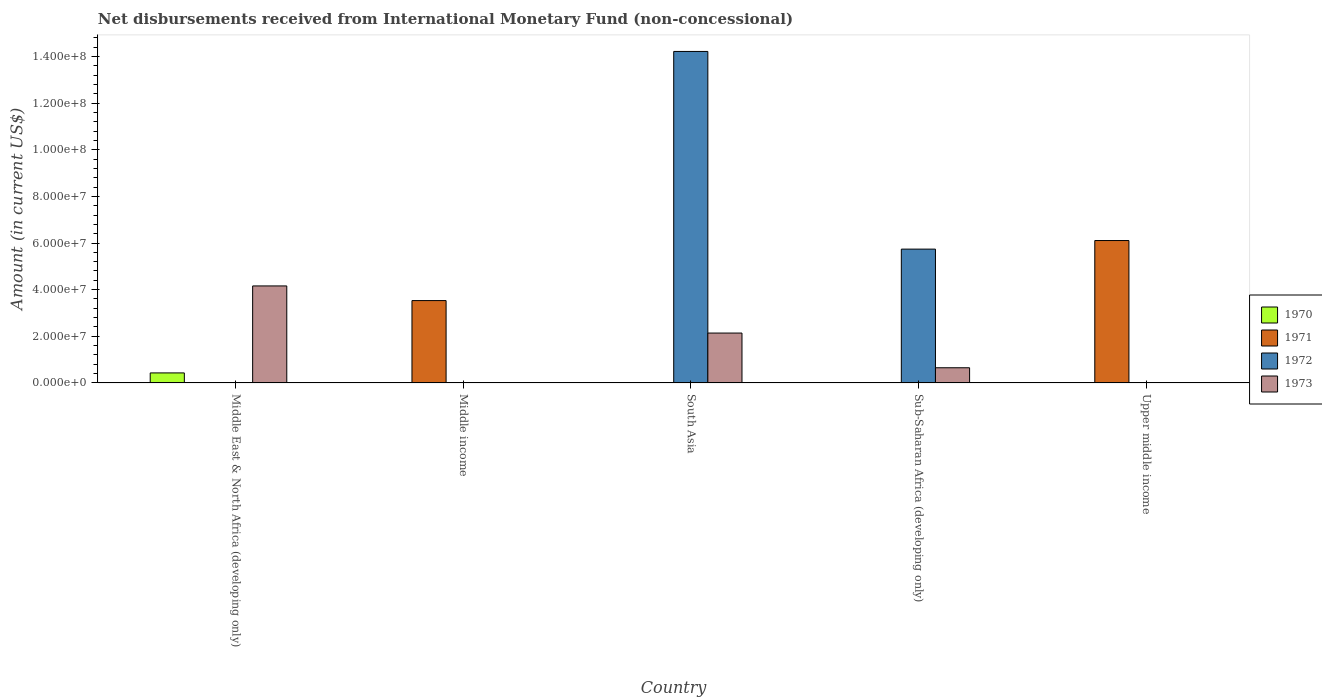How many different coloured bars are there?
Ensure brevity in your answer.  4. What is the label of the 4th group of bars from the left?
Provide a short and direct response. Sub-Saharan Africa (developing only). What is the amount of disbursements received from International Monetary Fund in 1970 in Middle East & North Africa (developing only)?
Offer a very short reply. 4.30e+06. Across all countries, what is the maximum amount of disbursements received from International Monetary Fund in 1971?
Make the answer very short. 6.11e+07. In which country was the amount of disbursements received from International Monetary Fund in 1972 maximum?
Give a very brief answer. South Asia. What is the total amount of disbursements received from International Monetary Fund in 1972 in the graph?
Make the answer very short. 2.00e+08. What is the difference between the amount of disbursements received from International Monetary Fund in 1971 in Middle income and that in Upper middle income?
Give a very brief answer. -2.57e+07. What is the difference between the amount of disbursements received from International Monetary Fund in 1973 in Upper middle income and the amount of disbursements received from International Monetary Fund in 1970 in Middle income?
Provide a short and direct response. 0. What is the average amount of disbursements received from International Monetary Fund in 1971 per country?
Make the answer very short. 1.93e+07. What is the difference between the amount of disbursements received from International Monetary Fund of/in 1973 and amount of disbursements received from International Monetary Fund of/in 1972 in South Asia?
Make the answer very short. -1.21e+08. In how many countries, is the amount of disbursements received from International Monetary Fund in 1971 greater than 4000000 US$?
Your response must be concise. 2. What is the ratio of the amount of disbursements received from International Monetary Fund in 1973 in South Asia to that in Sub-Saharan Africa (developing only)?
Your response must be concise. 3.29. Is the amount of disbursements received from International Monetary Fund in 1973 in Middle East & North Africa (developing only) less than that in Sub-Saharan Africa (developing only)?
Provide a short and direct response. No. What is the difference between the highest and the second highest amount of disbursements received from International Monetary Fund in 1973?
Keep it short and to the point. 3.51e+07. What is the difference between the highest and the lowest amount of disbursements received from International Monetary Fund in 1973?
Keep it short and to the point. 4.16e+07. Is it the case that in every country, the sum of the amount of disbursements received from International Monetary Fund in 1970 and amount of disbursements received from International Monetary Fund in 1971 is greater than the sum of amount of disbursements received from International Monetary Fund in 1973 and amount of disbursements received from International Monetary Fund in 1972?
Your answer should be compact. No. How many bars are there?
Provide a succinct answer. 8. Are all the bars in the graph horizontal?
Make the answer very short. No. Are the values on the major ticks of Y-axis written in scientific E-notation?
Provide a succinct answer. Yes. Does the graph contain any zero values?
Keep it short and to the point. Yes. Does the graph contain grids?
Offer a terse response. No. Where does the legend appear in the graph?
Provide a short and direct response. Center right. How are the legend labels stacked?
Provide a succinct answer. Vertical. What is the title of the graph?
Ensure brevity in your answer.  Net disbursements received from International Monetary Fund (non-concessional). Does "1999" appear as one of the legend labels in the graph?
Give a very brief answer. No. What is the label or title of the X-axis?
Provide a short and direct response. Country. What is the label or title of the Y-axis?
Provide a succinct answer. Amount (in current US$). What is the Amount (in current US$) of 1970 in Middle East & North Africa (developing only)?
Give a very brief answer. 4.30e+06. What is the Amount (in current US$) in 1972 in Middle East & North Africa (developing only)?
Provide a short and direct response. 0. What is the Amount (in current US$) in 1973 in Middle East & North Africa (developing only)?
Make the answer very short. 4.16e+07. What is the Amount (in current US$) in 1971 in Middle income?
Make the answer very short. 3.53e+07. What is the Amount (in current US$) in 1972 in Middle income?
Make the answer very short. 0. What is the Amount (in current US$) of 1973 in Middle income?
Your answer should be very brief. 0. What is the Amount (in current US$) of 1970 in South Asia?
Ensure brevity in your answer.  0. What is the Amount (in current US$) in 1972 in South Asia?
Your response must be concise. 1.42e+08. What is the Amount (in current US$) in 1973 in South Asia?
Keep it short and to the point. 2.14e+07. What is the Amount (in current US$) in 1970 in Sub-Saharan Africa (developing only)?
Give a very brief answer. 0. What is the Amount (in current US$) in 1971 in Sub-Saharan Africa (developing only)?
Your answer should be compact. 0. What is the Amount (in current US$) in 1972 in Sub-Saharan Africa (developing only)?
Your answer should be very brief. 5.74e+07. What is the Amount (in current US$) of 1973 in Sub-Saharan Africa (developing only)?
Your answer should be very brief. 6.51e+06. What is the Amount (in current US$) in 1971 in Upper middle income?
Ensure brevity in your answer.  6.11e+07. What is the Amount (in current US$) of 1972 in Upper middle income?
Offer a terse response. 0. What is the Amount (in current US$) of 1973 in Upper middle income?
Offer a very short reply. 0. Across all countries, what is the maximum Amount (in current US$) in 1970?
Your answer should be compact. 4.30e+06. Across all countries, what is the maximum Amount (in current US$) of 1971?
Offer a very short reply. 6.11e+07. Across all countries, what is the maximum Amount (in current US$) in 1972?
Ensure brevity in your answer.  1.42e+08. Across all countries, what is the maximum Amount (in current US$) of 1973?
Make the answer very short. 4.16e+07. Across all countries, what is the minimum Amount (in current US$) in 1971?
Your answer should be compact. 0. Across all countries, what is the minimum Amount (in current US$) of 1972?
Ensure brevity in your answer.  0. Across all countries, what is the minimum Amount (in current US$) of 1973?
Your answer should be compact. 0. What is the total Amount (in current US$) of 1970 in the graph?
Give a very brief answer. 4.30e+06. What is the total Amount (in current US$) in 1971 in the graph?
Provide a short and direct response. 9.64e+07. What is the total Amount (in current US$) in 1972 in the graph?
Your response must be concise. 2.00e+08. What is the total Amount (in current US$) of 1973 in the graph?
Offer a very short reply. 6.95e+07. What is the difference between the Amount (in current US$) of 1973 in Middle East & North Africa (developing only) and that in South Asia?
Ensure brevity in your answer.  2.02e+07. What is the difference between the Amount (in current US$) of 1973 in Middle East & North Africa (developing only) and that in Sub-Saharan Africa (developing only)?
Provide a succinct answer. 3.51e+07. What is the difference between the Amount (in current US$) in 1971 in Middle income and that in Upper middle income?
Ensure brevity in your answer.  -2.57e+07. What is the difference between the Amount (in current US$) of 1972 in South Asia and that in Sub-Saharan Africa (developing only)?
Provide a succinct answer. 8.48e+07. What is the difference between the Amount (in current US$) of 1973 in South Asia and that in Sub-Saharan Africa (developing only)?
Your response must be concise. 1.49e+07. What is the difference between the Amount (in current US$) of 1970 in Middle East & North Africa (developing only) and the Amount (in current US$) of 1971 in Middle income?
Provide a succinct answer. -3.10e+07. What is the difference between the Amount (in current US$) of 1970 in Middle East & North Africa (developing only) and the Amount (in current US$) of 1972 in South Asia?
Provide a short and direct response. -1.38e+08. What is the difference between the Amount (in current US$) of 1970 in Middle East & North Africa (developing only) and the Amount (in current US$) of 1973 in South Asia?
Make the answer very short. -1.71e+07. What is the difference between the Amount (in current US$) in 1970 in Middle East & North Africa (developing only) and the Amount (in current US$) in 1972 in Sub-Saharan Africa (developing only)?
Make the answer very short. -5.31e+07. What is the difference between the Amount (in current US$) in 1970 in Middle East & North Africa (developing only) and the Amount (in current US$) in 1973 in Sub-Saharan Africa (developing only)?
Offer a terse response. -2.21e+06. What is the difference between the Amount (in current US$) of 1970 in Middle East & North Africa (developing only) and the Amount (in current US$) of 1971 in Upper middle income?
Make the answer very short. -5.68e+07. What is the difference between the Amount (in current US$) of 1971 in Middle income and the Amount (in current US$) of 1972 in South Asia?
Give a very brief answer. -1.07e+08. What is the difference between the Amount (in current US$) in 1971 in Middle income and the Amount (in current US$) in 1973 in South Asia?
Your answer should be compact. 1.39e+07. What is the difference between the Amount (in current US$) in 1971 in Middle income and the Amount (in current US$) in 1972 in Sub-Saharan Africa (developing only)?
Provide a short and direct response. -2.21e+07. What is the difference between the Amount (in current US$) of 1971 in Middle income and the Amount (in current US$) of 1973 in Sub-Saharan Africa (developing only)?
Provide a succinct answer. 2.88e+07. What is the difference between the Amount (in current US$) in 1972 in South Asia and the Amount (in current US$) in 1973 in Sub-Saharan Africa (developing only)?
Your answer should be compact. 1.36e+08. What is the average Amount (in current US$) in 1970 per country?
Offer a very short reply. 8.60e+05. What is the average Amount (in current US$) in 1971 per country?
Keep it short and to the point. 1.93e+07. What is the average Amount (in current US$) in 1972 per country?
Provide a succinct answer. 3.99e+07. What is the average Amount (in current US$) of 1973 per country?
Ensure brevity in your answer.  1.39e+07. What is the difference between the Amount (in current US$) of 1970 and Amount (in current US$) of 1973 in Middle East & North Africa (developing only)?
Offer a terse response. -3.73e+07. What is the difference between the Amount (in current US$) in 1972 and Amount (in current US$) in 1973 in South Asia?
Offer a very short reply. 1.21e+08. What is the difference between the Amount (in current US$) of 1972 and Amount (in current US$) of 1973 in Sub-Saharan Africa (developing only)?
Offer a very short reply. 5.09e+07. What is the ratio of the Amount (in current US$) of 1973 in Middle East & North Africa (developing only) to that in South Asia?
Offer a very short reply. 1.94. What is the ratio of the Amount (in current US$) in 1973 in Middle East & North Africa (developing only) to that in Sub-Saharan Africa (developing only)?
Provide a succinct answer. 6.39. What is the ratio of the Amount (in current US$) of 1971 in Middle income to that in Upper middle income?
Your answer should be very brief. 0.58. What is the ratio of the Amount (in current US$) of 1972 in South Asia to that in Sub-Saharan Africa (developing only)?
Your answer should be very brief. 2.48. What is the ratio of the Amount (in current US$) of 1973 in South Asia to that in Sub-Saharan Africa (developing only)?
Your answer should be very brief. 3.29. What is the difference between the highest and the second highest Amount (in current US$) of 1973?
Your response must be concise. 2.02e+07. What is the difference between the highest and the lowest Amount (in current US$) of 1970?
Your response must be concise. 4.30e+06. What is the difference between the highest and the lowest Amount (in current US$) of 1971?
Offer a very short reply. 6.11e+07. What is the difference between the highest and the lowest Amount (in current US$) of 1972?
Your answer should be compact. 1.42e+08. What is the difference between the highest and the lowest Amount (in current US$) in 1973?
Your answer should be very brief. 4.16e+07. 